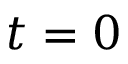<formula> <loc_0><loc_0><loc_500><loc_500>t = 0</formula> 